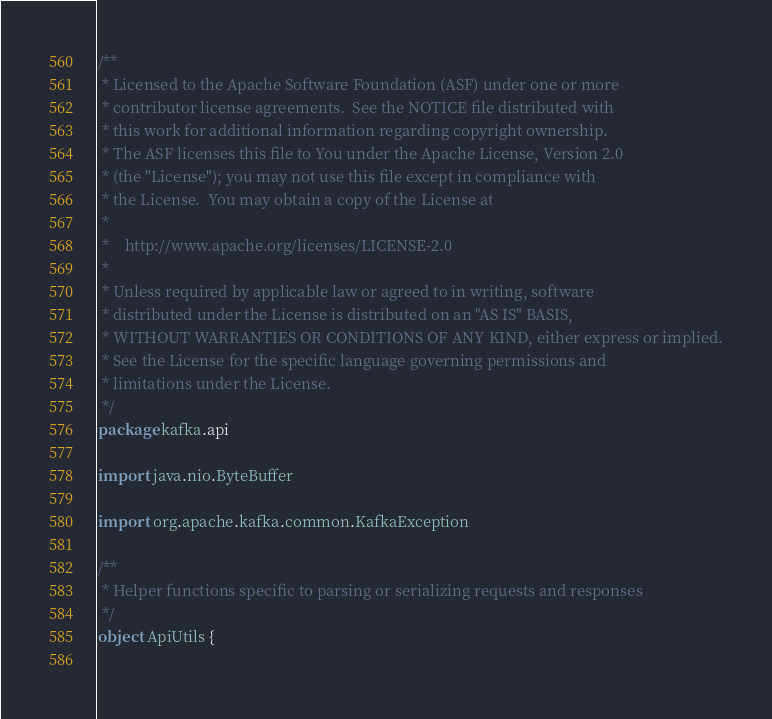<code> <loc_0><loc_0><loc_500><loc_500><_Scala_>/**
 * Licensed to the Apache Software Foundation (ASF) under one or more
 * contributor license agreements.  See the NOTICE file distributed with
 * this work for additional information regarding copyright ownership.
 * The ASF licenses this file to You under the Apache License, Version 2.0
 * (the "License"); you may not use this file except in compliance with
 * the License.  You may obtain a copy of the License at
 * 
 *    http://www.apache.org/licenses/LICENSE-2.0
 *
 * Unless required by applicable law or agreed to in writing, software
 * distributed under the License is distributed on an "AS IS" BASIS,
 * WITHOUT WARRANTIES OR CONDITIONS OF ANY KIND, either express or implied.
 * See the License for the specific language governing permissions and
 * limitations under the License.
 */
package kafka.api

import java.nio.ByteBuffer

import org.apache.kafka.common.KafkaException

/**
 * Helper functions specific to parsing or serializing requests and responses
 */
object ApiUtils {
  </code> 